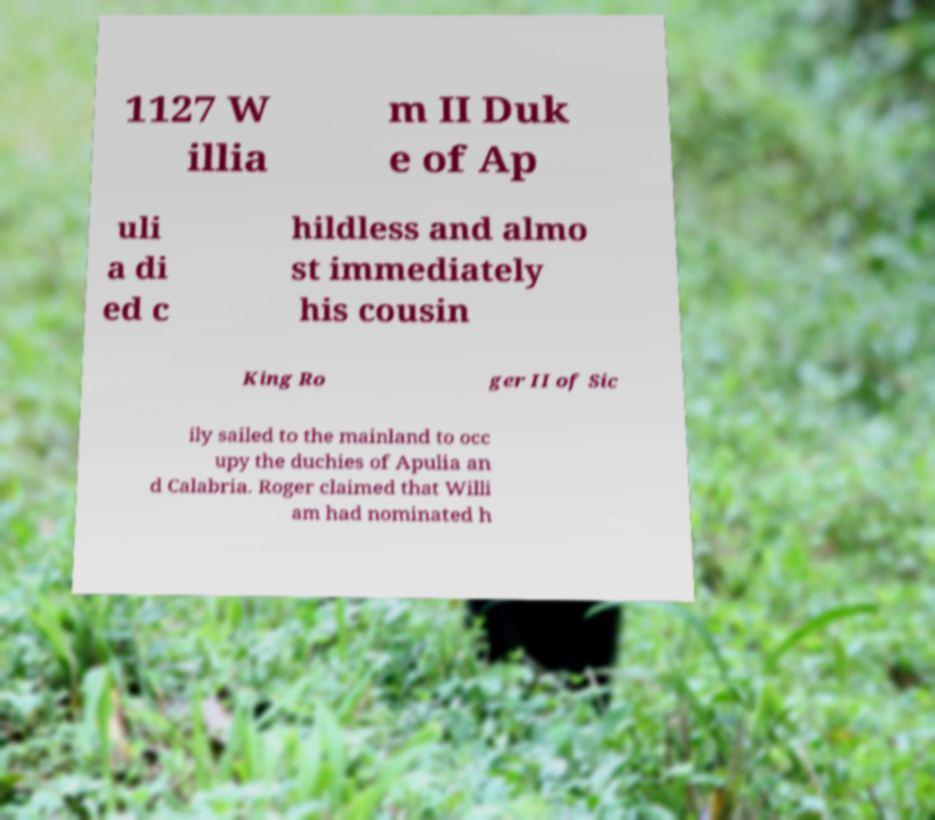Could you assist in decoding the text presented in this image and type it out clearly? 1127 W illia m II Duk e of Ap uli a di ed c hildless and almo st immediately his cousin King Ro ger II of Sic ily sailed to the mainland to occ upy the duchies of Apulia an d Calabria. Roger claimed that Willi am had nominated h 